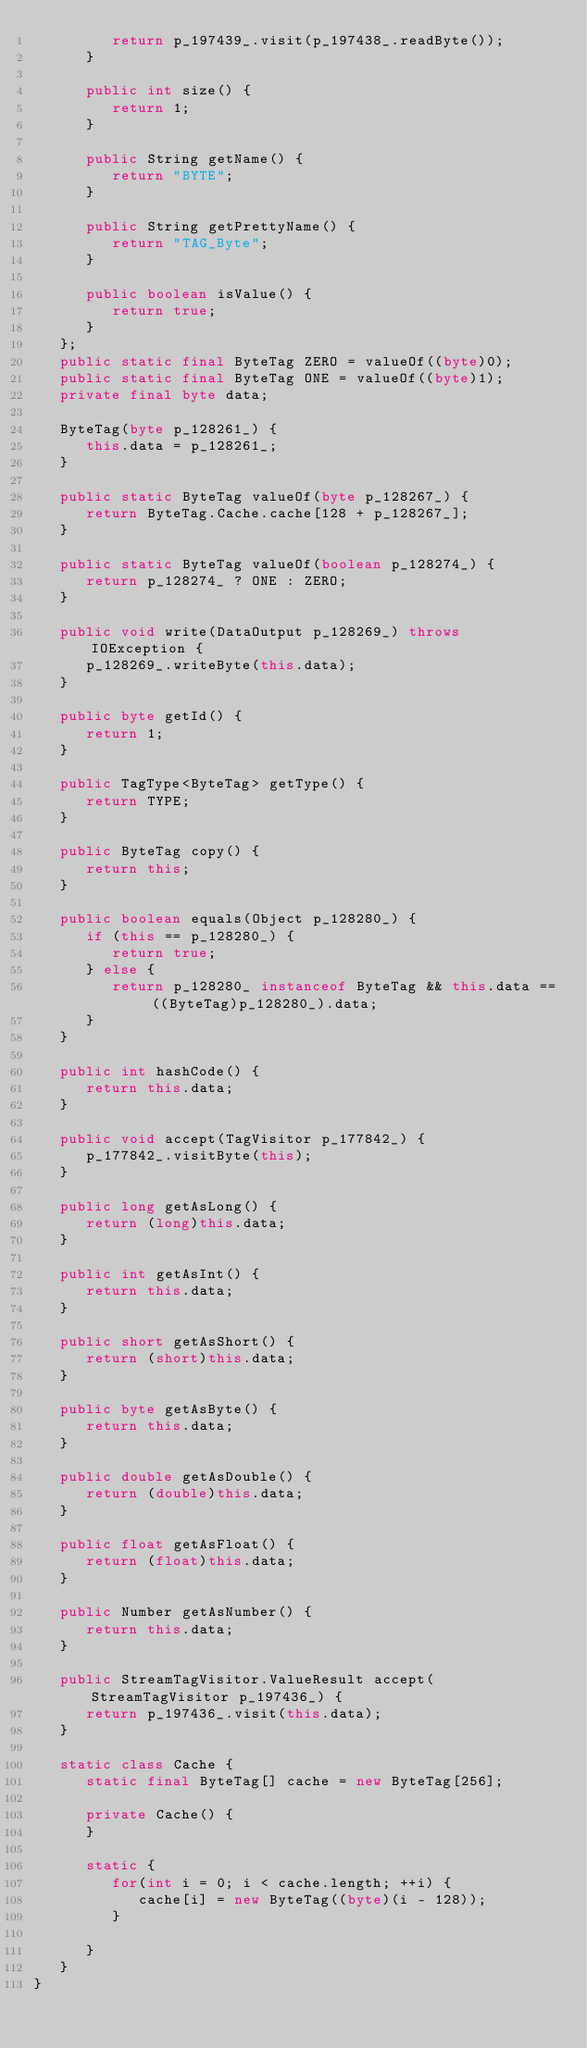<code> <loc_0><loc_0><loc_500><loc_500><_Java_>         return p_197439_.visit(p_197438_.readByte());
      }

      public int size() {
         return 1;
      }

      public String getName() {
         return "BYTE";
      }

      public String getPrettyName() {
         return "TAG_Byte";
      }

      public boolean isValue() {
         return true;
      }
   };
   public static final ByteTag ZERO = valueOf((byte)0);
   public static final ByteTag ONE = valueOf((byte)1);
   private final byte data;

   ByteTag(byte p_128261_) {
      this.data = p_128261_;
   }

   public static ByteTag valueOf(byte p_128267_) {
      return ByteTag.Cache.cache[128 + p_128267_];
   }

   public static ByteTag valueOf(boolean p_128274_) {
      return p_128274_ ? ONE : ZERO;
   }

   public void write(DataOutput p_128269_) throws IOException {
      p_128269_.writeByte(this.data);
   }

   public byte getId() {
      return 1;
   }

   public TagType<ByteTag> getType() {
      return TYPE;
   }

   public ByteTag copy() {
      return this;
   }

   public boolean equals(Object p_128280_) {
      if (this == p_128280_) {
         return true;
      } else {
         return p_128280_ instanceof ByteTag && this.data == ((ByteTag)p_128280_).data;
      }
   }

   public int hashCode() {
      return this.data;
   }

   public void accept(TagVisitor p_177842_) {
      p_177842_.visitByte(this);
   }

   public long getAsLong() {
      return (long)this.data;
   }

   public int getAsInt() {
      return this.data;
   }

   public short getAsShort() {
      return (short)this.data;
   }

   public byte getAsByte() {
      return this.data;
   }

   public double getAsDouble() {
      return (double)this.data;
   }

   public float getAsFloat() {
      return (float)this.data;
   }

   public Number getAsNumber() {
      return this.data;
   }

   public StreamTagVisitor.ValueResult accept(StreamTagVisitor p_197436_) {
      return p_197436_.visit(this.data);
   }

   static class Cache {
      static final ByteTag[] cache = new ByteTag[256];

      private Cache() {
      }

      static {
         for(int i = 0; i < cache.length; ++i) {
            cache[i] = new ByteTag((byte)(i - 128));
         }

      }
   }
}</code> 